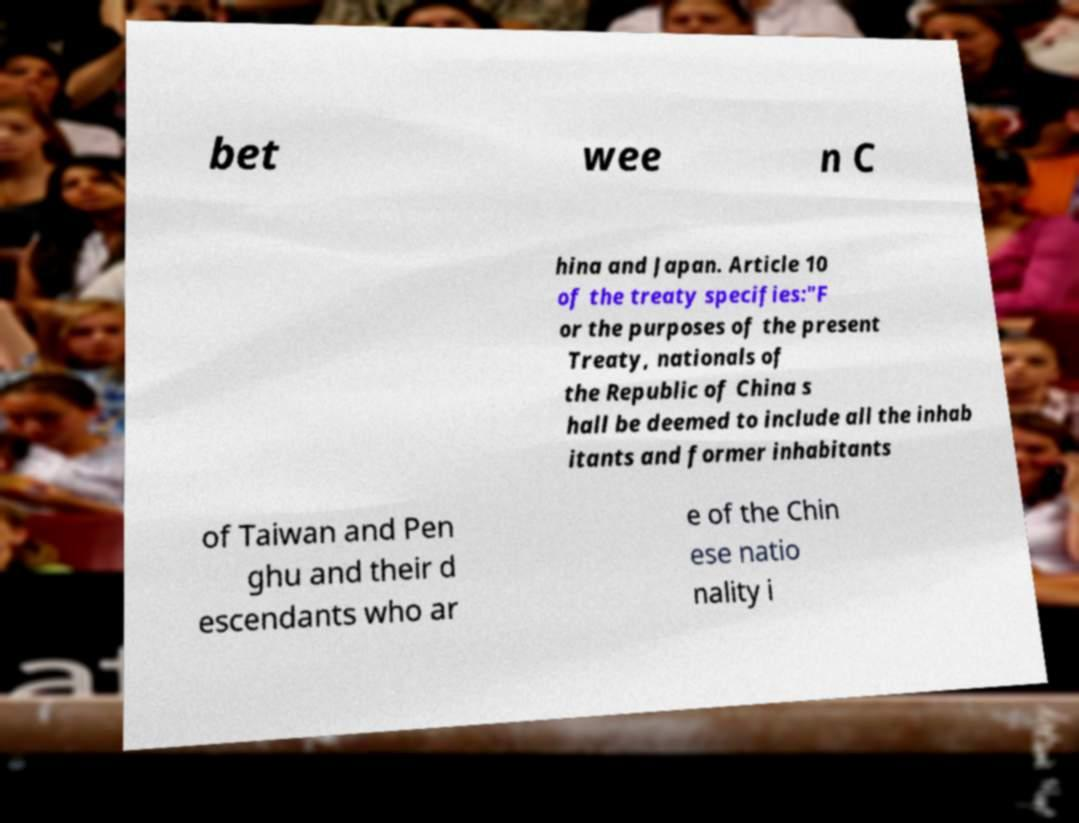Could you assist in decoding the text presented in this image and type it out clearly? bet wee n C hina and Japan. Article 10 of the treaty specifies:"F or the purposes of the present Treaty, nationals of the Republic of China s hall be deemed to include all the inhab itants and former inhabitants of Taiwan and Pen ghu and their d escendants who ar e of the Chin ese natio nality i 